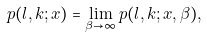<formula> <loc_0><loc_0><loc_500><loc_500>p ( l , k ; { x } ) = \lim _ { \beta \rightarrow \infty } p ( l , k ; { x } , \beta ) ,</formula> 